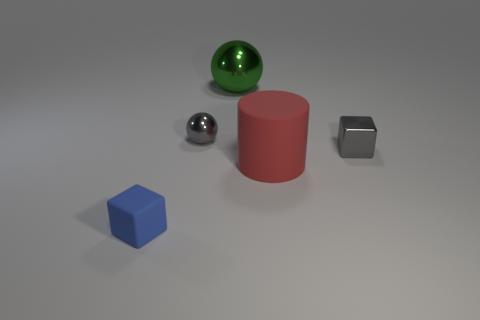Add 1 large yellow rubber cylinders. How many objects exist? 6 Subtract all spheres. How many objects are left? 3 Subtract all big blue matte balls. Subtract all tiny cubes. How many objects are left? 3 Add 1 cylinders. How many cylinders are left? 2 Add 5 balls. How many balls exist? 7 Subtract 0 cyan balls. How many objects are left? 5 